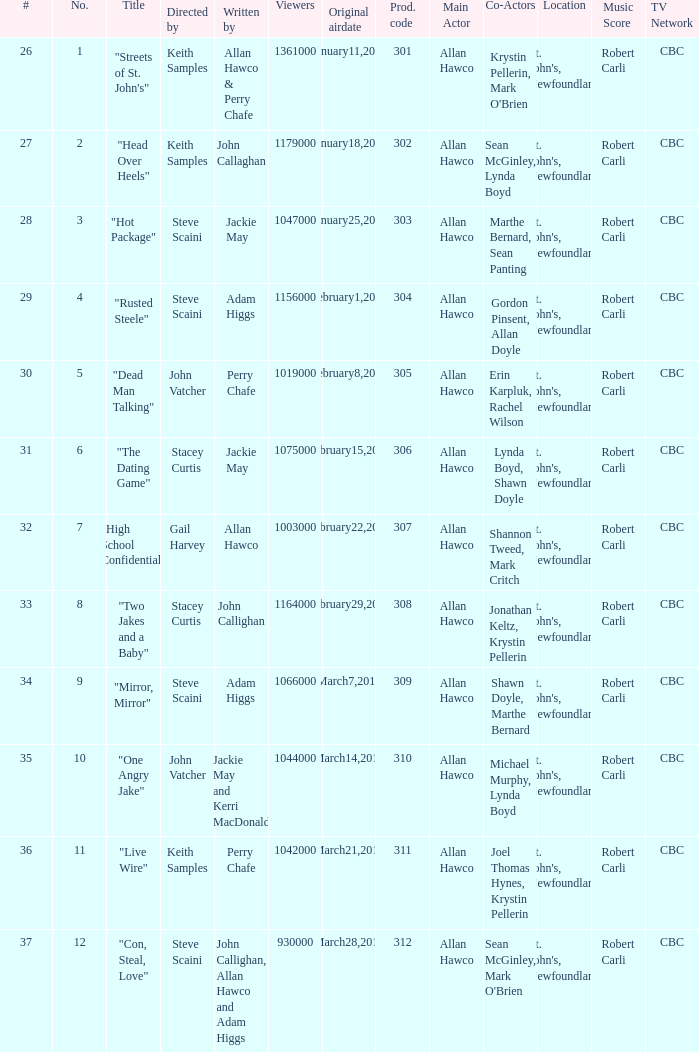What is the number of original airdate written by allan hawco? 1.0. 